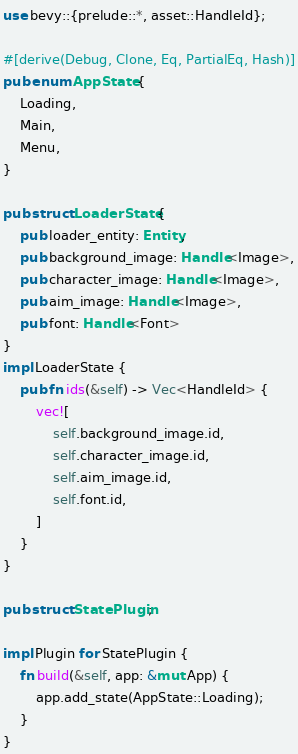Convert code to text. <code><loc_0><loc_0><loc_500><loc_500><_Rust_>use bevy::{prelude::*, asset::HandleId};

#[derive(Debug, Clone, Eq, PartialEq, Hash)]
pub enum AppState {
    Loading,
    Main,
    Menu,
}

pub struct LoaderState {
    pub loader_entity: Entity,
    pub background_image: Handle<Image>,
    pub character_image: Handle<Image>,
    pub aim_image: Handle<Image>,
    pub font: Handle<Font>
}
impl LoaderState {
    pub fn ids(&self) -> Vec<HandleId> {
        vec![
            self.background_image.id,
            self.character_image.id,
            self.aim_image.id,
            self.font.id,
        ]
    }
}

pub struct StatePlugin;

impl Plugin for StatePlugin {
    fn build(&self, app: &mut App) {
        app.add_state(AppState::Loading);
    }
}
</code> 